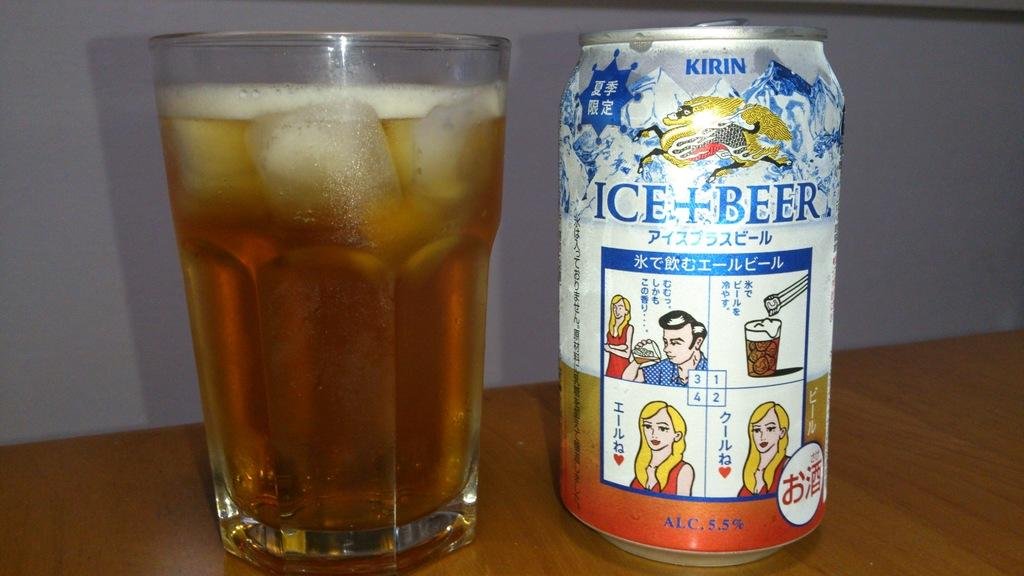Provide a one-sentence caption for the provided image. an ice and beer can next to a cup. 